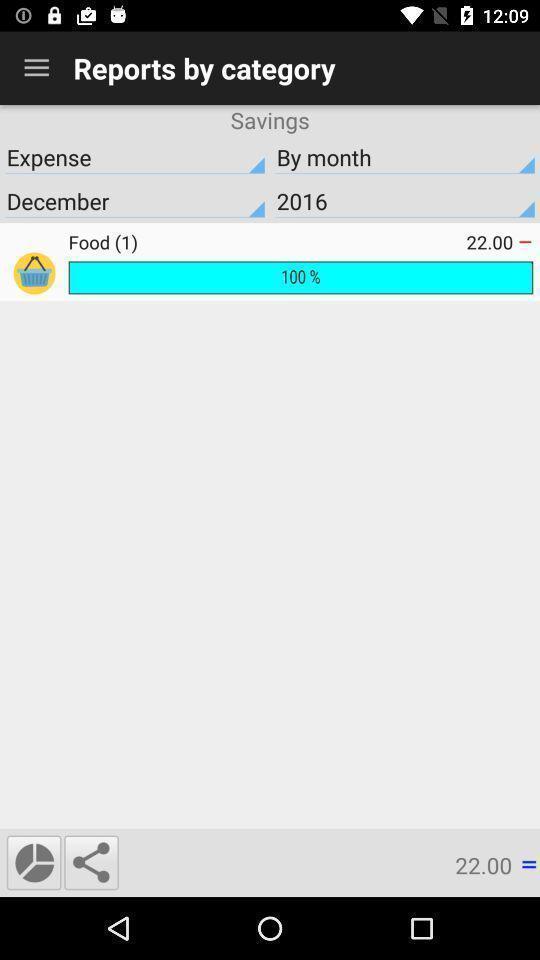Describe the visual elements of this screenshot. Page displaying various categories. 